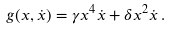Convert formula to latex. <formula><loc_0><loc_0><loc_500><loc_500>g ( x , \dot { x } ) = \gamma x ^ { 4 } \dot { x } + \delta x ^ { 2 } \dot { x } \, .</formula> 